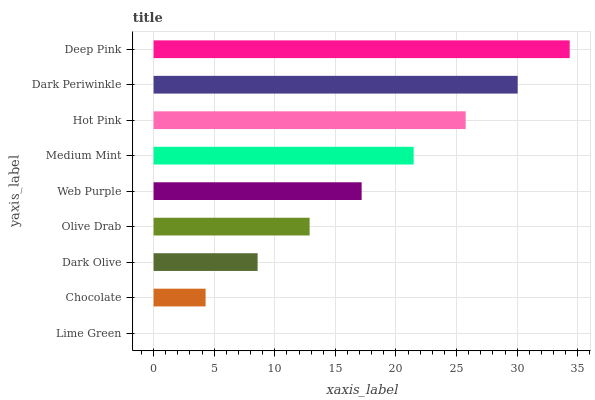Is Lime Green the minimum?
Answer yes or no. Yes. Is Deep Pink the maximum?
Answer yes or no. Yes. Is Chocolate the minimum?
Answer yes or no. No. Is Chocolate the maximum?
Answer yes or no. No. Is Chocolate greater than Lime Green?
Answer yes or no. Yes. Is Lime Green less than Chocolate?
Answer yes or no. Yes. Is Lime Green greater than Chocolate?
Answer yes or no. No. Is Chocolate less than Lime Green?
Answer yes or no. No. Is Web Purple the high median?
Answer yes or no. Yes. Is Web Purple the low median?
Answer yes or no. Yes. Is Dark Periwinkle the high median?
Answer yes or no. No. Is Dark Olive the low median?
Answer yes or no. No. 